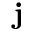<formula> <loc_0><loc_0><loc_500><loc_500>j</formula> 